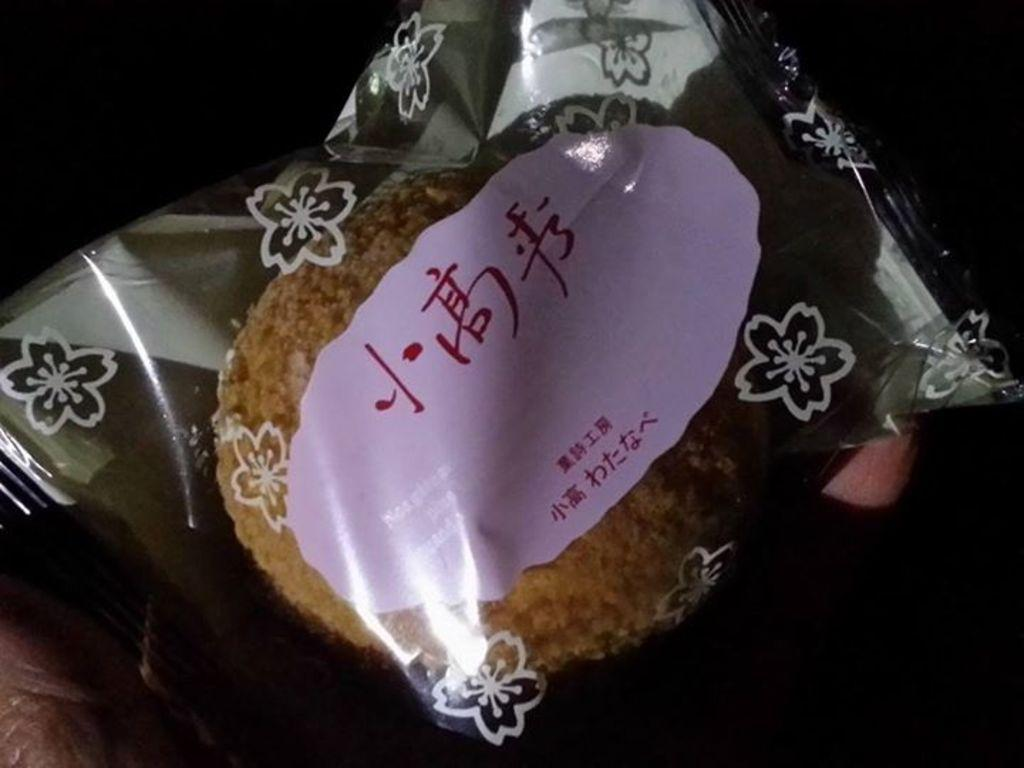What is present in the image related to food? There is food in the image. How is the food contained or packaged? The food is in a polythene cover. Is there any text visible on the polythene cover? Yes, there is text visible on the polythene cover. What type of chain is being used to hold the books in the image? There are no books or chains present in the image; it only features food in a polythene cover with visible text. 